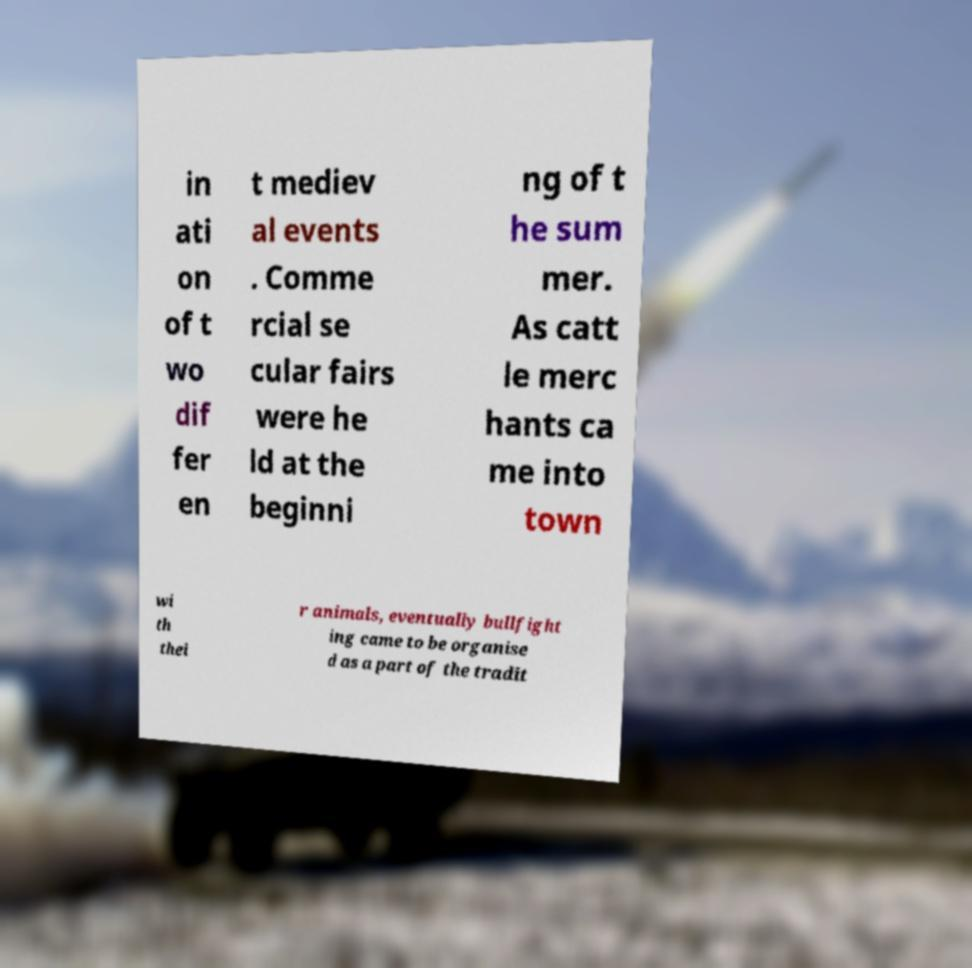Please read and relay the text visible in this image. What does it say? in ati on of t wo dif fer en t mediev al events . Comme rcial se cular fairs were he ld at the beginni ng of t he sum mer. As catt le merc hants ca me into town wi th thei r animals, eventually bullfight ing came to be organise d as a part of the tradit 